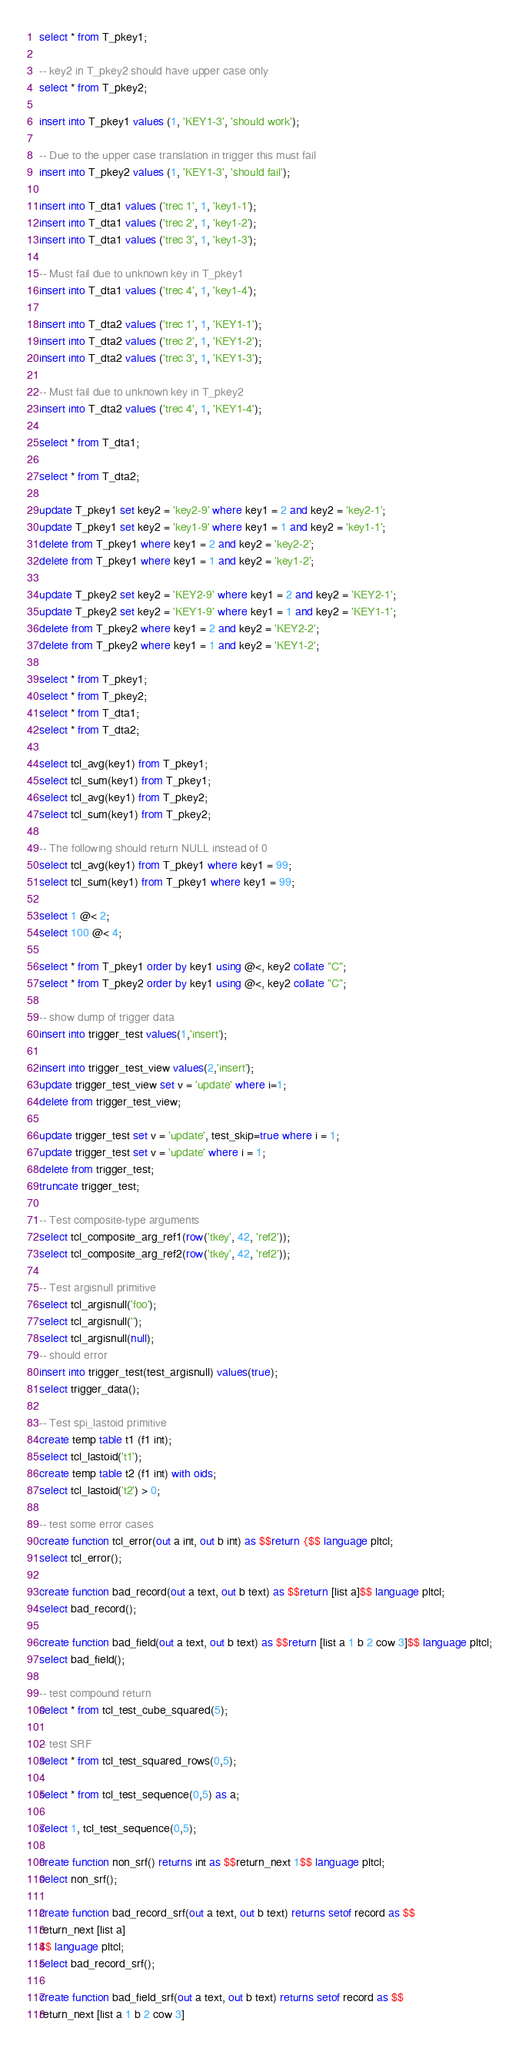Convert code to text. <code><loc_0><loc_0><loc_500><loc_500><_SQL_>select * from T_pkey1;

-- key2 in T_pkey2 should have upper case only
select * from T_pkey2;

insert into T_pkey1 values (1, 'KEY1-3', 'should work');

-- Due to the upper case translation in trigger this must fail
insert into T_pkey2 values (1, 'KEY1-3', 'should fail');

insert into T_dta1 values ('trec 1', 1, 'key1-1');
insert into T_dta1 values ('trec 2', 1, 'key1-2');
insert into T_dta1 values ('trec 3', 1, 'key1-3');

-- Must fail due to unknown key in T_pkey1
insert into T_dta1 values ('trec 4', 1, 'key1-4');

insert into T_dta2 values ('trec 1', 1, 'KEY1-1');
insert into T_dta2 values ('trec 2', 1, 'KEY1-2');
insert into T_dta2 values ('trec 3', 1, 'KEY1-3');

-- Must fail due to unknown key in T_pkey2
insert into T_dta2 values ('trec 4', 1, 'KEY1-4');

select * from T_dta1;

select * from T_dta2;

update T_pkey1 set key2 = 'key2-9' where key1 = 2 and key2 = 'key2-1';
update T_pkey1 set key2 = 'key1-9' where key1 = 1 and key2 = 'key1-1';
delete from T_pkey1 where key1 = 2 and key2 = 'key2-2';
delete from T_pkey1 where key1 = 1 and key2 = 'key1-2';

update T_pkey2 set key2 = 'KEY2-9' where key1 = 2 and key2 = 'KEY2-1';
update T_pkey2 set key2 = 'KEY1-9' where key1 = 1 and key2 = 'KEY1-1';
delete from T_pkey2 where key1 = 2 and key2 = 'KEY2-2';
delete from T_pkey2 where key1 = 1 and key2 = 'KEY1-2';

select * from T_pkey1;
select * from T_pkey2;
select * from T_dta1;
select * from T_dta2;

select tcl_avg(key1) from T_pkey1;
select tcl_sum(key1) from T_pkey1;
select tcl_avg(key1) from T_pkey2;
select tcl_sum(key1) from T_pkey2;

-- The following should return NULL instead of 0
select tcl_avg(key1) from T_pkey1 where key1 = 99;
select tcl_sum(key1) from T_pkey1 where key1 = 99;

select 1 @< 2;
select 100 @< 4;

select * from T_pkey1 order by key1 using @<, key2 collate "C";
select * from T_pkey2 order by key1 using @<, key2 collate "C";

-- show dump of trigger data
insert into trigger_test values(1,'insert');

insert into trigger_test_view values(2,'insert');
update trigger_test_view set v = 'update' where i=1;
delete from trigger_test_view;

update trigger_test set v = 'update', test_skip=true where i = 1;
update trigger_test set v = 'update' where i = 1;
delete from trigger_test;
truncate trigger_test;

-- Test composite-type arguments
select tcl_composite_arg_ref1(row('tkey', 42, 'ref2'));
select tcl_composite_arg_ref2(row('tkey', 42, 'ref2'));

-- Test argisnull primitive
select tcl_argisnull('foo');
select tcl_argisnull('');
select tcl_argisnull(null);
-- should error
insert into trigger_test(test_argisnull) values(true);
select trigger_data();

-- Test spi_lastoid primitive
create temp table t1 (f1 int);
select tcl_lastoid('t1');
create temp table t2 (f1 int) with oids;
select tcl_lastoid('t2') > 0;

-- test some error cases
create function tcl_error(out a int, out b int) as $$return {$$ language pltcl;
select tcl_error();

create function bad_record(out a text, out b text) as $$return [list a]$$ language pltcl;
select bad_record();

create function bad_field(out a text, out b text) as $$return [list a 1 b 2 cow 3]$$ language pltcl;
select bad_field();

-- test compound return
select * from tcl_test_cube_squared(5);

-- test SRF
select * from tcl_test_squared_rows(0,5);

select * from tcl_test_sequence(0,5) as a;

select 1, tcl_test_sequence(0,5);

create function non_srf() returns int as $$return_next 1$$ language pltcl;
select non_srf();

create function bad_record_srf(out a text, out b text) returns setof record as $$
return_next [list a]
$$ language pltcl;
select bad_record_srf();

create function bad_field_srf(out a text, out b text) returns setof record as $$
return_next [list a 1 b 2 cow 3]</code> 